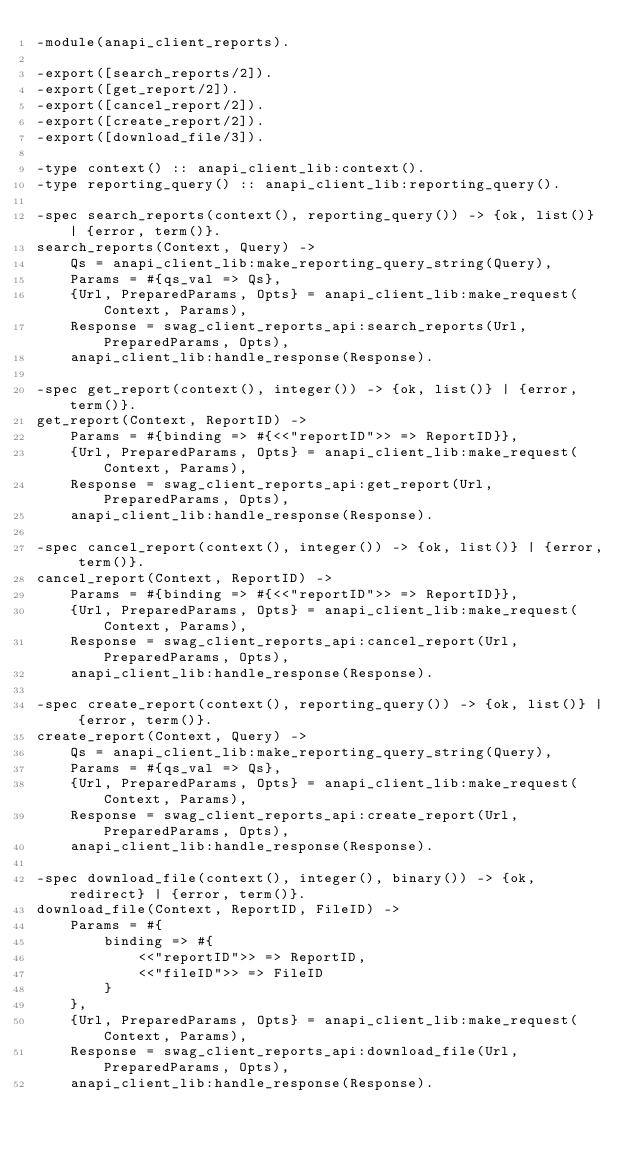Convert code to text. <code><loc_0><loc_0><loc_500><loc_500><_Erlang_>-module(anapi_client_reports).

-export([search_reports/2]).
-export([get_report/2]).
-export([cancel_report/2]).
-export([create_report/2]).
-export([download_file/3]).

-type context() :: anapi_client_lib:context().
-type reporting_query() :: anapi_client_lib:reporting_query().

-spec search_reports(context(), reporting_query()) -> {ok, list()} | {error, term()}.
search_reports(Context, Query) ->
    Qs = anapi_client_lib:make_reporting_query_string(Query),
    Params = #{qs_val => Qs},
    {Url, PreparedParams, Opts} = anapi_client_lib:make_request(Context, Params),
    Response = swag_client_reports_api:search_reports(Url, PreparedParams, Opts),
    anapi_client_lib:handle_response(Response).

-spec get_report(context(), integer()) -> {ok, list()} | {error, term()}.
get_report(Context, ReportID) ->
    Params = #{binding => #{<<"reportID">> => ReportID}},
    {Url, PreparedParams, Opts} = anapi_client_lib:make_request(Context, Params),
    Response = swag_client_reports_api:get_report(Url, PreparedParams, Opts),
    anapi_client_lib:handle_response(Response).

-spec cancel_report(context(), integer()) -> {ok, list()} | {error, term()}.
cancel_report(Context, ReportID) ->
    Params = #{binding => #{<<"reportID">> => ReportID}},
    {Url, PreparedParams, Opts} = anapi_client_lib:make_request(Context, Params),
    Response = swag_client_reports_api:cancel_report(Url, PreparedParams, Opts),
    anapi_client_lib:handle_response(Response).

-spec create_report(context(), reporting_query()) -> {ok, list()} | {error, term()}.
create_report(Context, Query) ->
    Qs = anapi_client_lib:make_reporting_query_string(Query),
    Params = #{qs_val => Qs},
    {Url, PreparedParams, Opts} = anapi_client_lib:make_request(Context, Params),
    Response = swag_client_reports_api:create_report(Url, PreparedParams, Opts),
    anapi_client_lib:handle_response(Response).

-spec download_file(context(), integer(), binary()) -> {ok, redirect} | {error, term()}.
download_file(Context, ReportID, FileID) ->
    Params = #{
        binding => #{
            <<"reportID">> => ReportID,
            <<"fileID">> => FileID
        }
    },
    {Url, PreparedParams, Opts} = anapi_client_lib:make_request(Context, Params),
    Response = swag_client_reports_api:download_file(Url, PreparedParams, Opts),
    anapi_client_lib:handle_response(Response).
</code> 